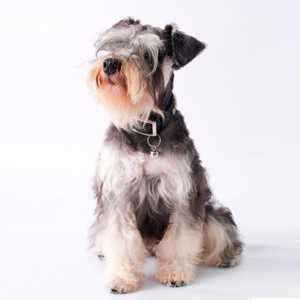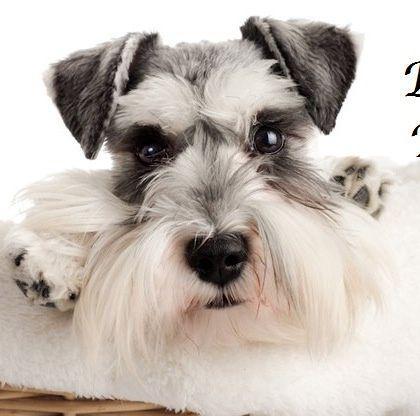The first image is the image on the left, the second image is the image on the right. For the images displayed, is the sentence "One of the images shows a dog that is standing." factually correct? Answer yes or no. No. 